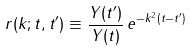<formula> <loc_0><loc_0><loc_500><loc_500>r ( k ; t , t ^ { \prime } ) \equiv \frac { Y ( t ^ { \prime } ) } { Y ( t ) } \, e ^ { - k ^ { 2 } ( t - t ^ { \prime } ) }</formula> 